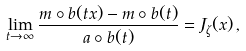Convert formula to latex. <formula><loc_0><loc_0><loc_500><loc_500>\lim _ { t \to \infty } \frac { m \circ b ( t x ) - m \circ b ( t ) } { a \circ b ( t ) } = J _ { \zeta } ( x ) \, ,</formula> 